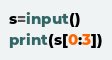Convert code to text. <code><loc_0><loc_0><loc_500><loc_500><_Python_>s=input()
print(s[0:3])</code> 